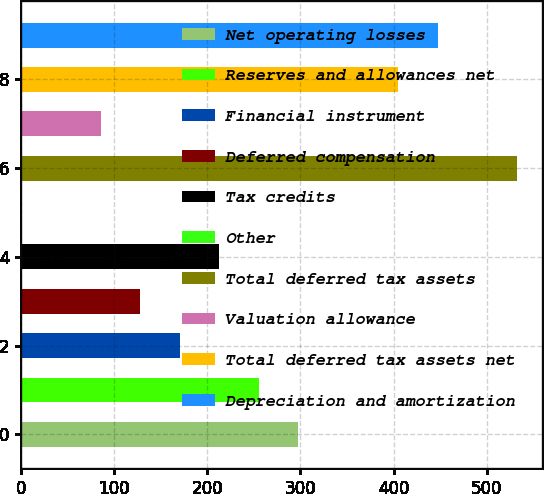Convert chart to OTSL. <chart><loc_0><loc_0><loc_500><loc_500><bar_chart><fcel>Net operating losses<fcel>Reserves and allowances net<fcel>Financial instrument<fcel>Deferred compensation<fcel>Tax credits<fcel>Other<fcel>Total deferred tax assets<fcel>Valuation allowance<fcel>Total deferred tax assets net<fcel>Depreciation and amortization<nl><fcel>297.8<fcel>255.4<fcel>170.6<fcel>128.2<fcel>213<fcel>1<fcel>532.2<fcel>85.8<fcel>405<fcel>447.4<nl></chart> 